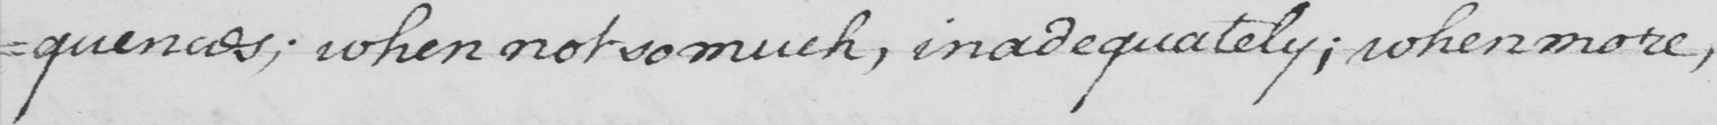Can you read and transcribe this handwriting? -quences; when not so much, inadequately; when more, 